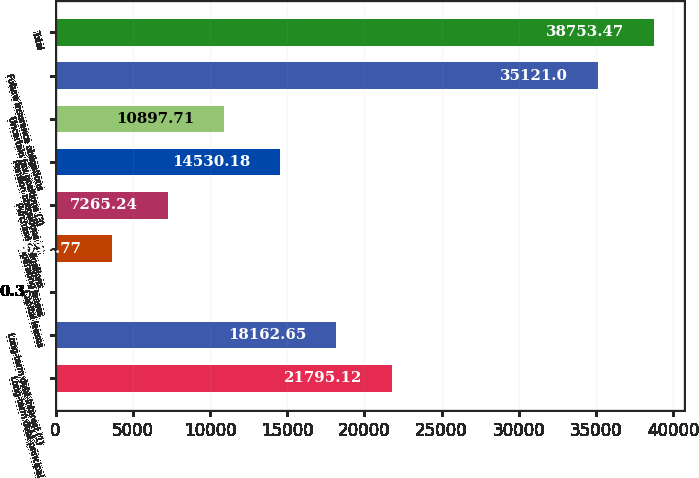<chart> <loc_0><loc_0><loc_500><loc_500><bar_chart><fcel>Long-term debt-principal<fcel>Long-term debt-interest (1)<fcel>Capital leases<fcel>Operating leases<fcel>Purchase obligations<fcel>Pension obligations (2)<fcel>Uncertain tax positions (3)<fcel>Future insurance obligations<fcel>Total<nl><fcel>21795.1<fcel>18162.7<fcel>0.3<fcel>3632.77<fcel>7265.24<fcel>14530.2<fcel>10897.7<fcel>35121<fcel>38753.5<nl></chart> 